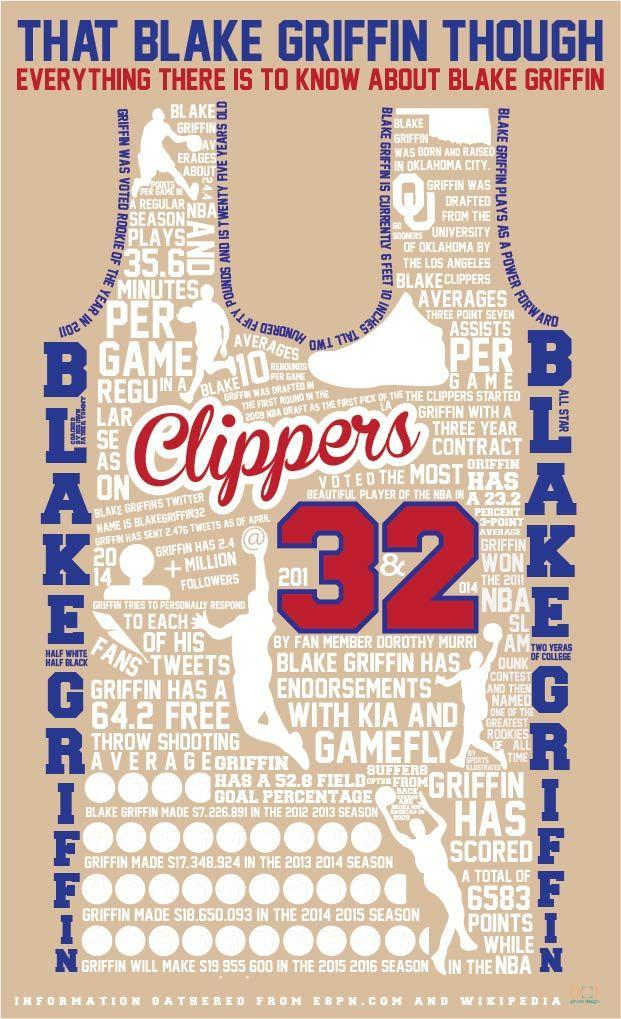Mention a couple of crucial points in this snapshot. The Twitter user known as "Black Griffin" goes by the username "blakegriffin32. 